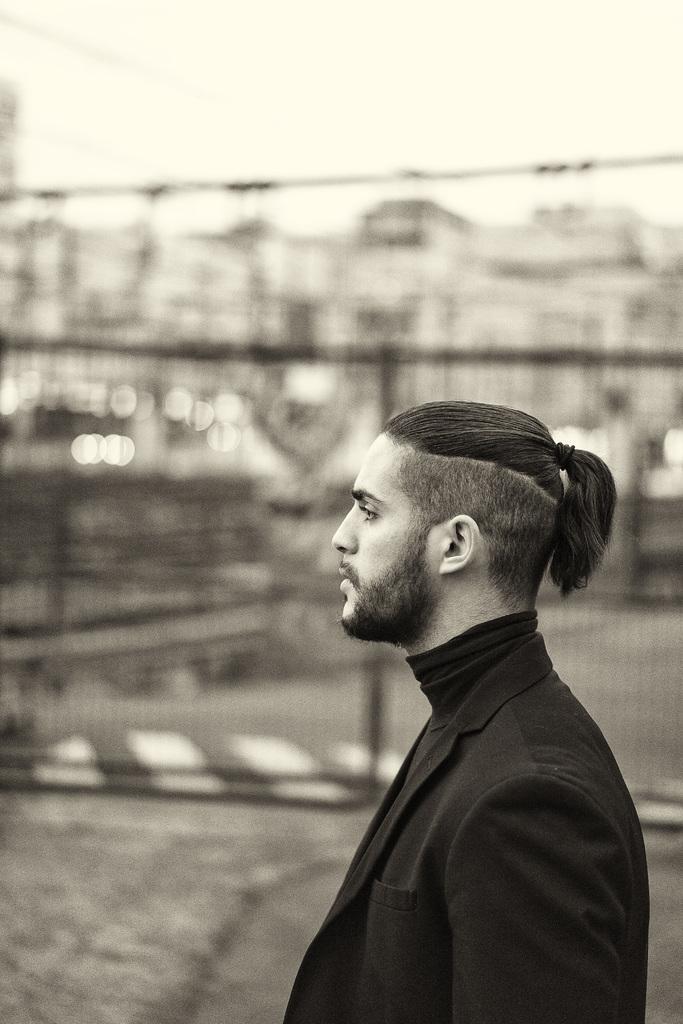Could you give a brief overview of what you see in this image? In the image we can see there is a person standing and he is wearing a black colour suit. The image is in black and white colour. 